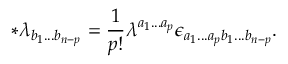<formula> <loc_0><loc_0><loc_500><loc_500>\ast \lambda _ { b _ { 1 } \dots b _ { n - p } } = \frac { 1 } p ! } \lambda ^ { a _ { 1 } \dots a _ { p } } \epsilon _ { a _ { 1 } \dots a _ { p } b _ { 1 } \dots b _ { n - p } } .</formula> 